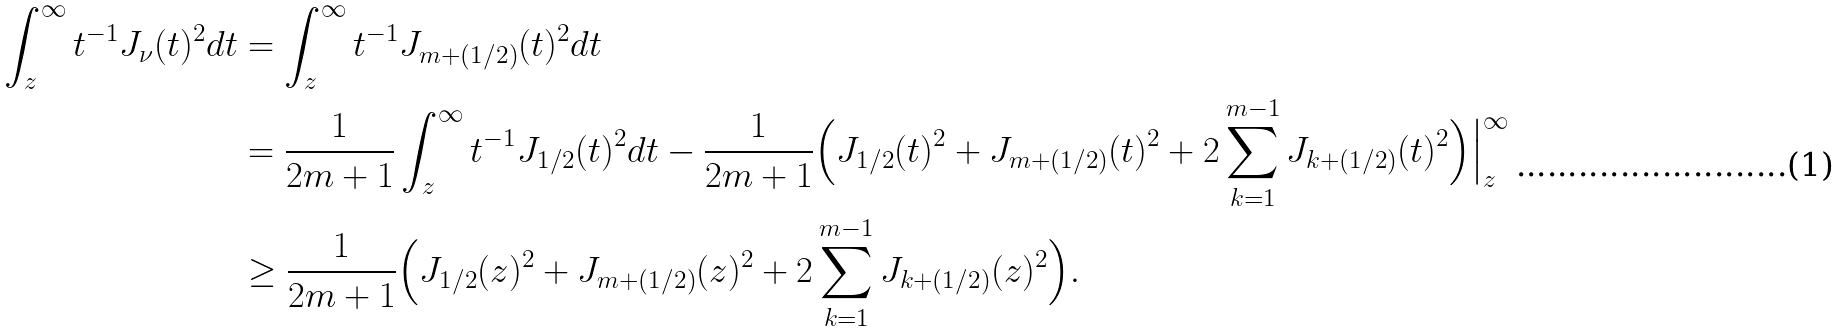Convert formula to latex. <formula><loc_0><loc_0><loc_500><loc_500>\int _ { z } ^ { \infty } t ^ { - 1 } J _ { \nu } ( t ) ^ { 2 } d t & = \int _ { z } ^ { \infty } t ^ { - 1 } J _ { m + ( 1 / 2 ) } ( t ) ^ { 2 } d t \\ & = \frac { 1 } { 2 m + 1 } \int _ { z } ^ { \infty } t ^ { - 1 } J _ { 1 / 2 } ( t ) ^ { 2 } d t - \frac { 1 } { 2 m + 1 } \Big ( J _ { 1 / 2 } ( t ) ^ { 2 } + J _ { m + ( 1 / 2 ) } ( t ) ^ { 2 } + 2 \sum _ { k = 1 } ^ { m - 1 } J _ { k + ( 1 / 2 ) } ( t ) ^ { 2 } \Big ) \Big | _ { z } ^ { \infty } \\ & \geq \frac { 1 } { 2 m + 1 } \Big ( J _ { 1 / 2 } ( z ) ^ { 2 } + J _ { m + ( 1 / 2 ) } ( z ) ^ { 2 } + 2 \sum _ { k = 1 } ^ { m - 1 } J _ { k + ( 1 / 2 ) } ( z ) ^ { 2 } \Big ) .</formula> 